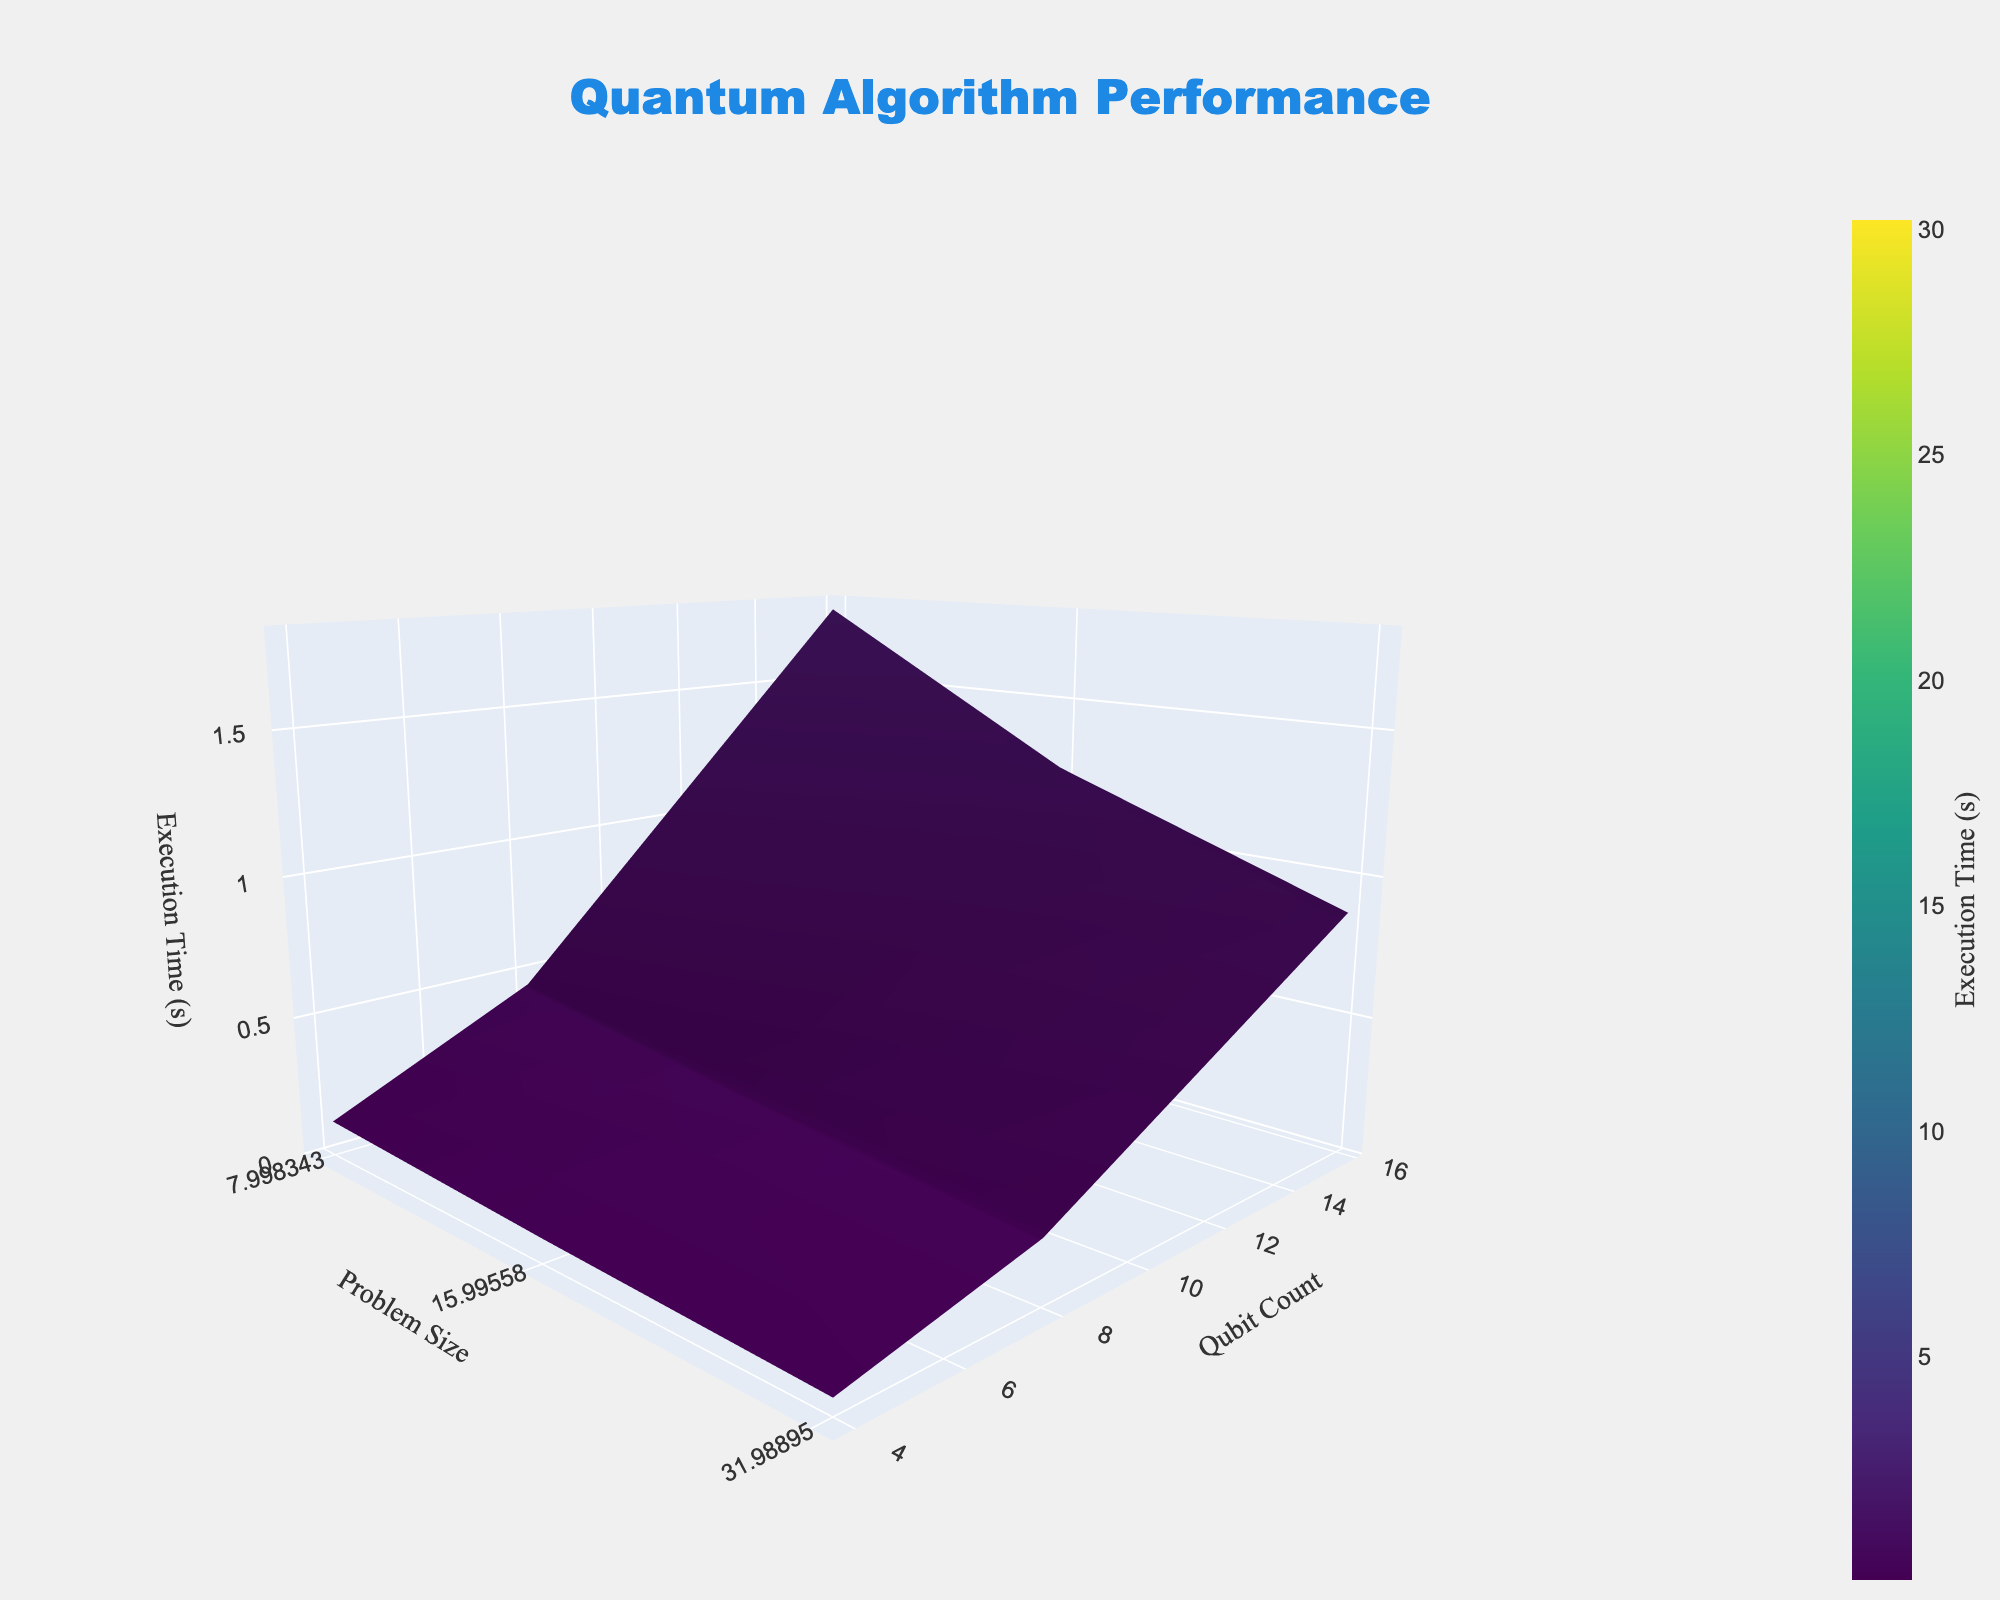What's the title of the figure? The title of the figure is located at the top and is easily readable. It indicates the overall theme represented by the 3D surface plot. The title is "Quantum Algorithm Performance."
Answer: Quantum Algorithm Performance What are the labels of each axis? The labels of the axes are given to show what each axis represents in the 3D plot. The x-axis represents "Problem Size," the y-axis represents "Qubit Count," and the z-axis represents "Execution Time (s)."
Answer: Problem Size, Qubit Count, Execution Time (s) Which color represents the shortest execution time? By examining the color scale indicated on the right side of the plot, we see that the colors towards the bottom of the scale represent the shortest execution times. For the 'Viridis' colorscale, the darkest shades signify the shortest times.
Answer: Darkest shades At what Qubit Count and Problem Size is the execution time around 30 seconds? We need to locate the peak on the z-axis close to the value of 30 seconds. By comparing the values, we find a data point corresponding closely to these conditions at Qubit Count 4 and Problem Size 128.
Answer: Qubit Count 4 and Problem Size 128 How does the execution time change as the problem size increases at a fixed qubit count of 16? To answer this, observe the surface plot along the line where the qubit count is constant at 16 while varying the problem size. The trend shows that the execution time increases as the problem size increases.
Answer: Increases Among problem sizes 8, 16, 32, 64, and 128, which one has the smallest execution time at a qubit count of 8? By locating the points along the y-axis for a qubit count of 8, we can compare the z-values. Problem Size 8 has the smallest execution time at this qubit count.
Answer: Problem Size 8 How does the shape of the surface change as qubit count increases? Observing from the left (low qubit counts) to the right (high qubit counts) and the corresponding z-values, the surface tends to flatten, indicating that higher qubit counts generally reduce execution time for increasing problem sizes, forming a descending slope.
Answer: Flattens and slopes downward Which combination of problem size and qubit count results in the longest execution time? By identifying the highest peak on the z-axis, we find that the combination of Problem Size 128 and Qubit Count 4 results in the longest execution time. This combination corresponds to the highest point on the 3D surface plot.
Answer: Problem Size 128 and Qubit Count 4 